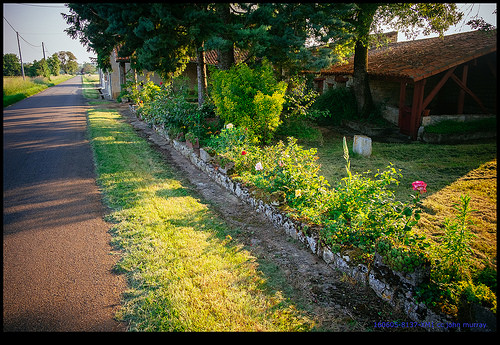<image>
Is the shack above the rose? Yes. The shack is positioned above the rose in the vertical space, higher up in the scene. 